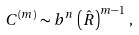Convert formula to latex. <formula><loc_0><loc_0><loc_500><loc_500>C ^ { ( m ) } \sim b ^ { n } \, \left ( \hat { R } \right ) ^ { m - 1 } \, ,</formula> 